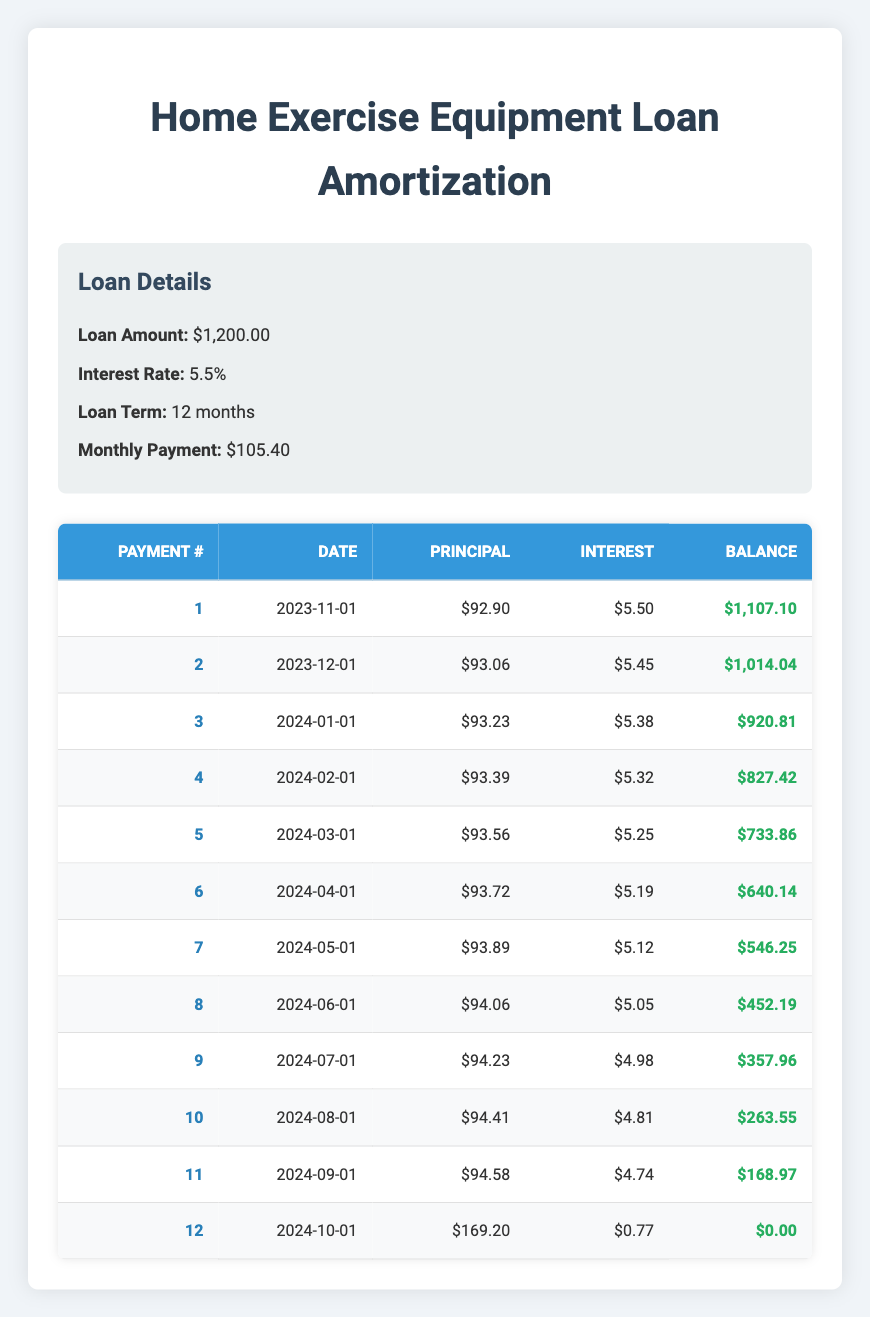What is the total loan amount for the home exercise equipment? The loan amount is given directly in the loan details section of the table as $1,200.00.
Answer: 1200.00 What is the monthly payment amount? The monthly payment is listed in the loan details section of the table as $105.40.
Answer: 105.40 How much is the principal payment in the 5th month? For the 5th month, the principal payment is found in the amortization schedule, which is $93.56.
Answer: 93.56 What is the total interest paid over the entire loan period? To find the total interest paid, add all the interest payments from each month: (5.50 + 5.45 + 5.38 + 5.32 + 5.25 + 5.19 + 5.12 + 5.05 + 4.98 + 4.81 + 4.74 + 0.77) = 56.09.
Answer: 56.09 In the second month, was the principal payment more than the interest payment? The principal payment in the second month is $93.06, and the interest payment is $5.45. Since 93.06 > 5.45, the statement is true.
Answer: Yes What is the remaining balance after the 8th payment? The remaining balance after the 8th payment is listed in the amortization schedule as $452.19.
Answer: 452.19 Which month has the highest principal payment and what is that amount? The highest principal payment can be found in the 12th month, which is $169.20.
Answer: 169.20 How much of the 11th payment goes towards the interest? In the 11th payment, the interest payment is $4.74, as captured in the amortization schedule.
Answer: 4.74 What is the total of the principal payments made after the first six months? To find the total principal payments for the first six months, add the principal payments for these months together: (92.90 + 93.06 + 93.23 + 93.39 + 93.56 + 93.72) = 559.86.
Answer: 559.86 Was the interest payment in the 10th month less than $5? The interest payment in the 10th month is $4.81, which is less than $5, making the statement true.
Answer: Yes 